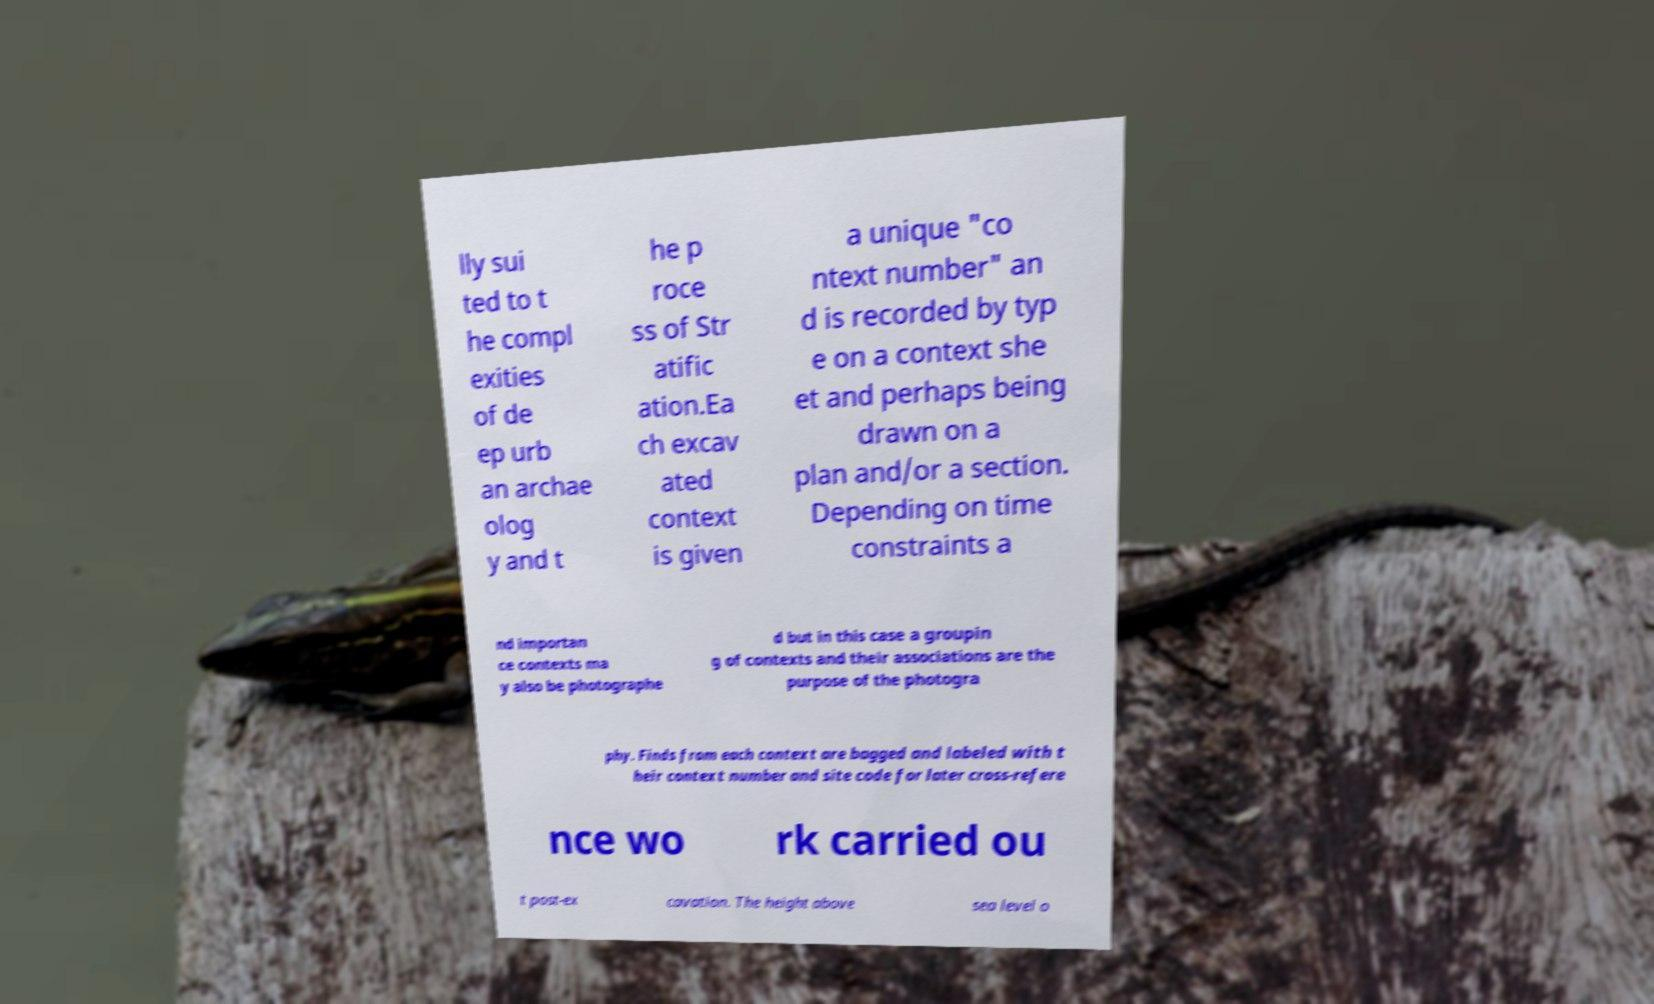Please read and relay the text visible in this image. What does it say? lly sui ted to t he compl exities of de ep urb an archae olog y and t he p roce ss of Str atific ation.Ea ch excav ated context is given a unique "co ntext number" an d is recorded by typ e on a context she et and perhaps being drawn on a plan and/or a section. Depending on time constraints a nd importan ce contexts ma y also be photographe d but in this case a groupin g of contexts and their associations are the purpose of the photogra phy. Finds from each context are bagged and labeled with t heir context number and site code for later cross-refere nce wo rk carried ou t post-ex cavation. The height above sea level o 